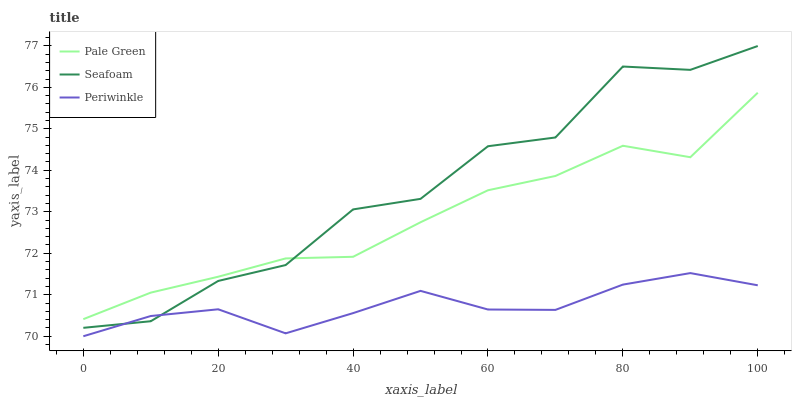Does Periwinkle have the minimum area under the curve?
Answer yes or no. Yes. Does Seafoam have the maximum area under the curve?
Answer yes or no. Yes. Does Seafoam have the minimum area under the curve?
Answer yes or no. No. Does Periwinkle have the maximum area under the curve?
Answer yes or no. No. Is Periwinkle the smoothest?
Answer yes or no. Yes. Is Seafoam the roughest?
Answer yes or no. Yes. Is Seafoam the smoothest?
Answer yes or no. No. Is Periwinkle the roughest?
Answer yes or no. No. Does Periwinkle have the lowest value?
Answer yes or no. Yes. Does Seafoam have the lowest value?
Answer yes or no. No. Does Seafoam have the highest value?
Answer yes or no. Yes. Does Periwinkle have the highest value?
Answer yes or no. No. Is Periwinkle less than Pale Green?
Answer yes or no. Yes. Is Pale Green greater than Periwinkle?
Answer yes or no. Yes. Does Pale Green intersect Seafoam?
Answer yes or no. Yes. Is Pale Green less than Seafoam?
Answer yes or no. No. Is Pale Green greater than Seafoam?
Answer yes or no. No. Does Periwinkle intersect Pale Green?
Answer yes or no. No. 